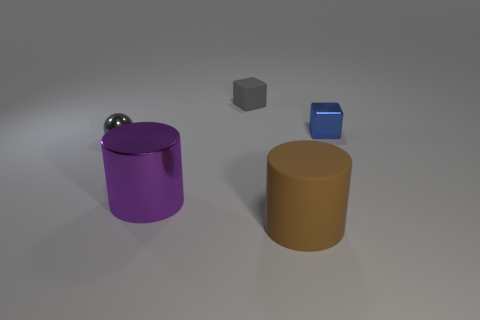Add 2 small gray metallic objects. How many objects exist? 7 Subtract all balls. How many objects are left? 4 Subtract all gray metal things. Subtract all brown cylinders. How many objects are left? 3 Add 3 brown matte cylinders. How many brown matte cylinders are left? 4 Add 3 metallic balls. How many metallic balls exist? 4 Subtract 1 gray cubes. How many objects are left? 4 